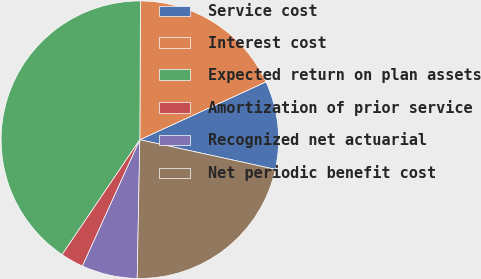<chart> <loc_0><loc_0><loc_500><loc_500><pie_chart><fcel>Service cost<fcel>Interest cost<fcel>Expected return on plan assets<fcel>Amortization of prior service<fcel>Recognized net actuarial<fcel>Net periodic benefit cost<nl><fcel>10.27%<fcel>18.09%<fcel>40.6%<fcel>2.68%<fcel>6.48%<fcel>21.88%<nl></chart> 